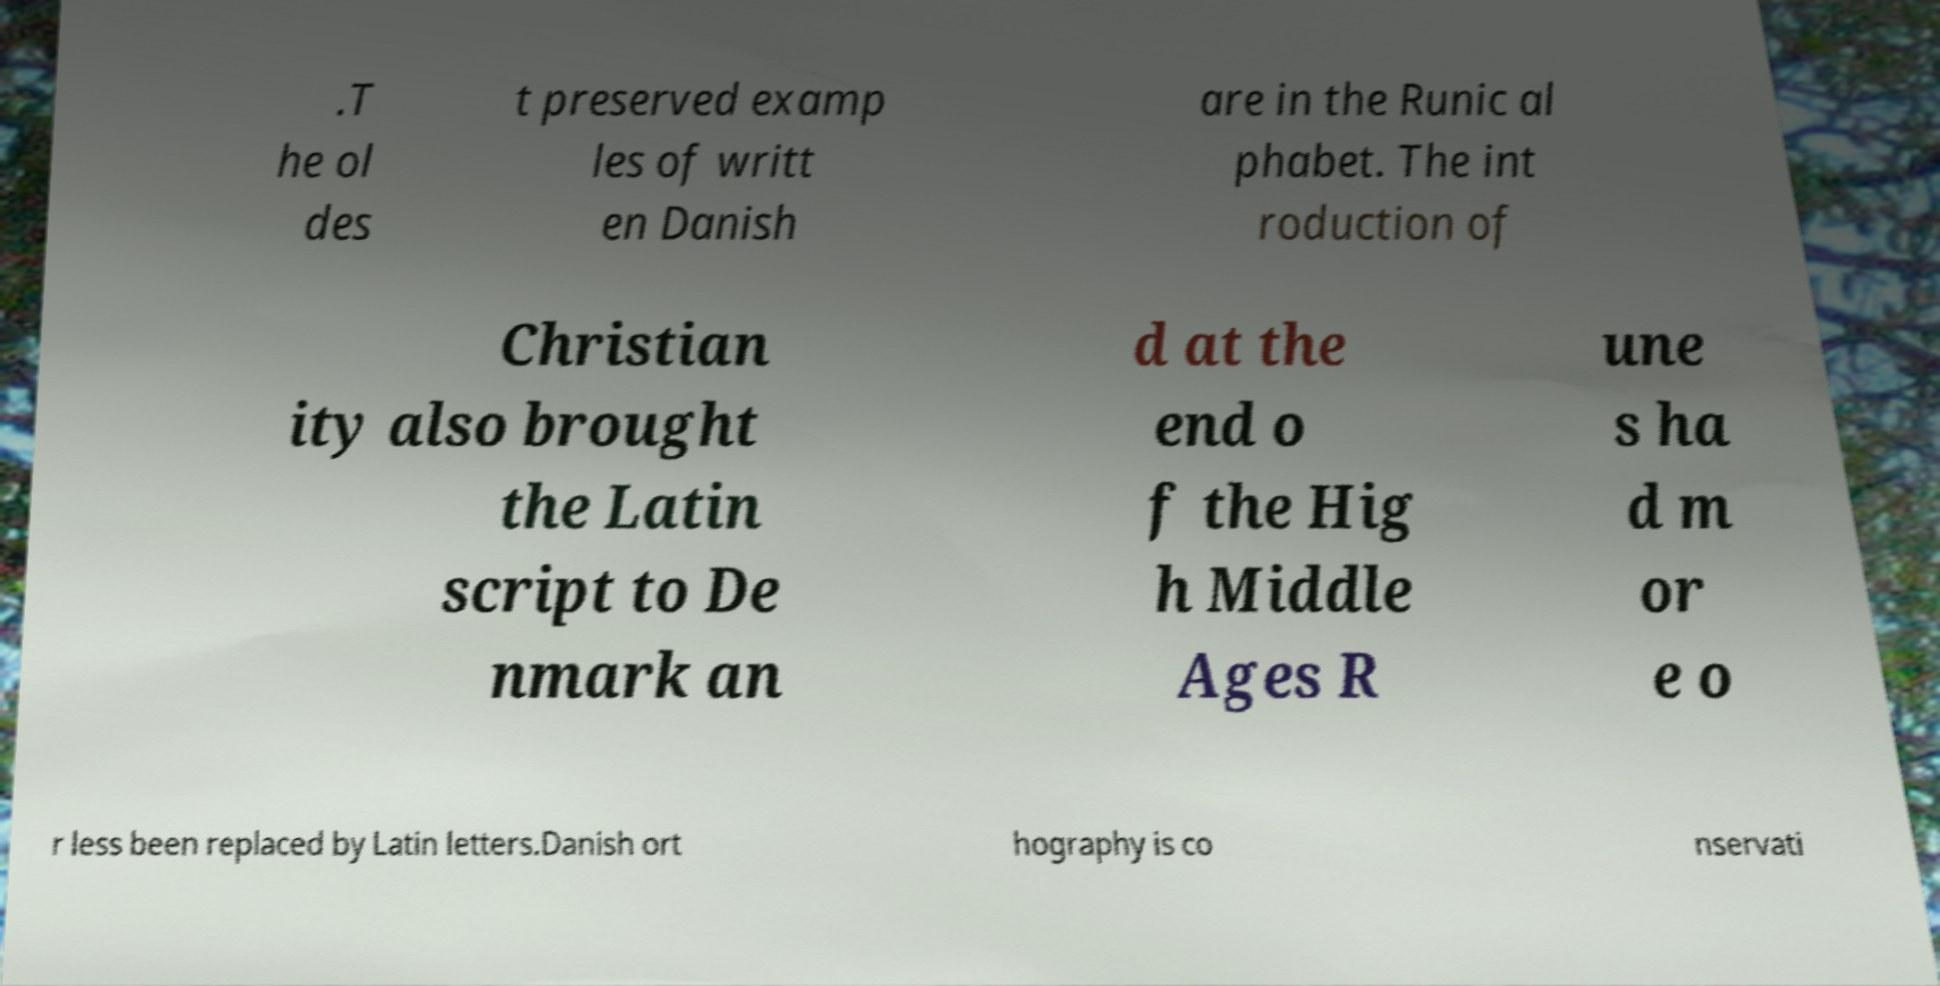Please identify and transcribe the text found in this image. .T he ol des t preserved examp les of writt en Danish are in the Runic al phabet. The int roduction of Christian ity also brought the Latin script to De nmark an d at the end o f the Hig h Middle Ages R une s ha d m or e o r less been replaced by Latin letters.Danish ort hography is co nservati 